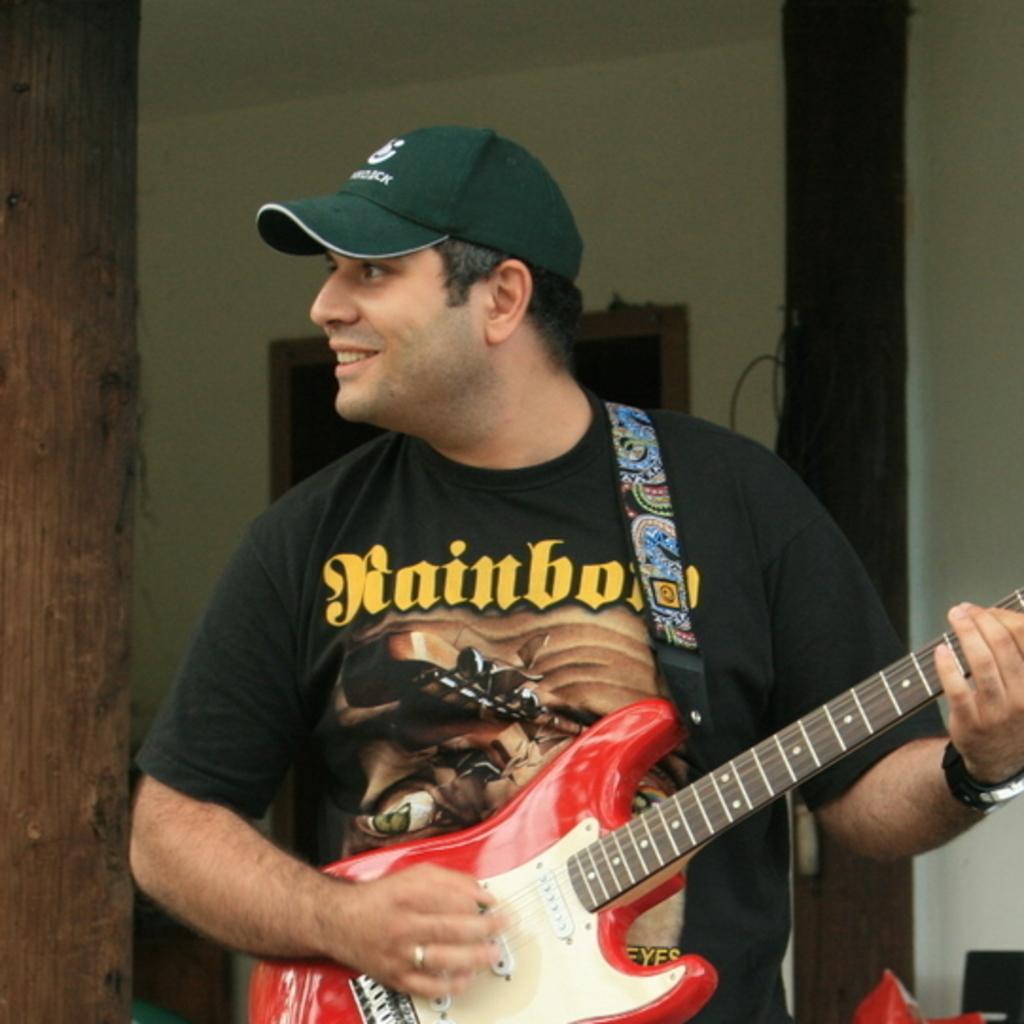Can you describe this image briefly? I can see a man wearing a black T-shirt holding and playing guitar. He is wearing a wrist watch and a cap on his hand. At background I can see a tree trunk and wall. 